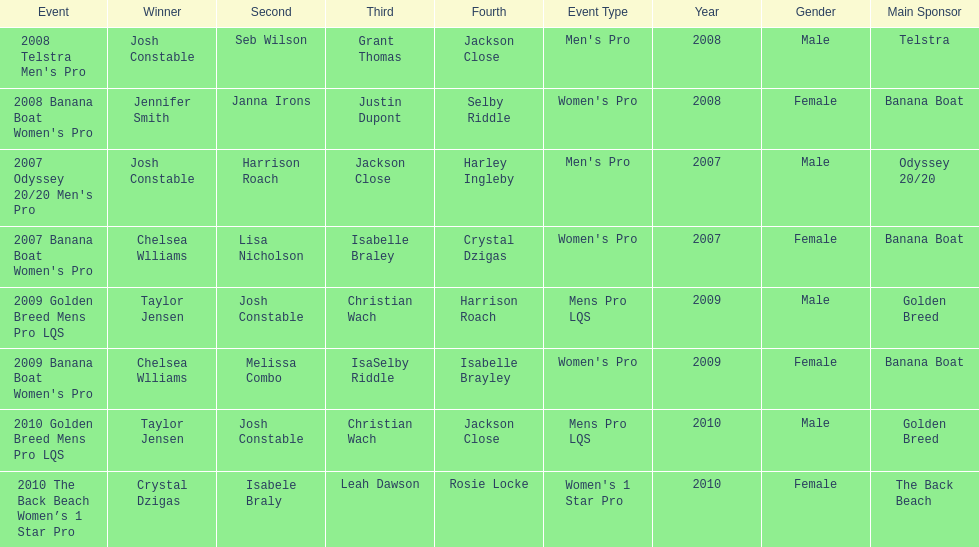Who was next to finish after josh constable in the 2008 telstra men's pro? Seb Wilson. 